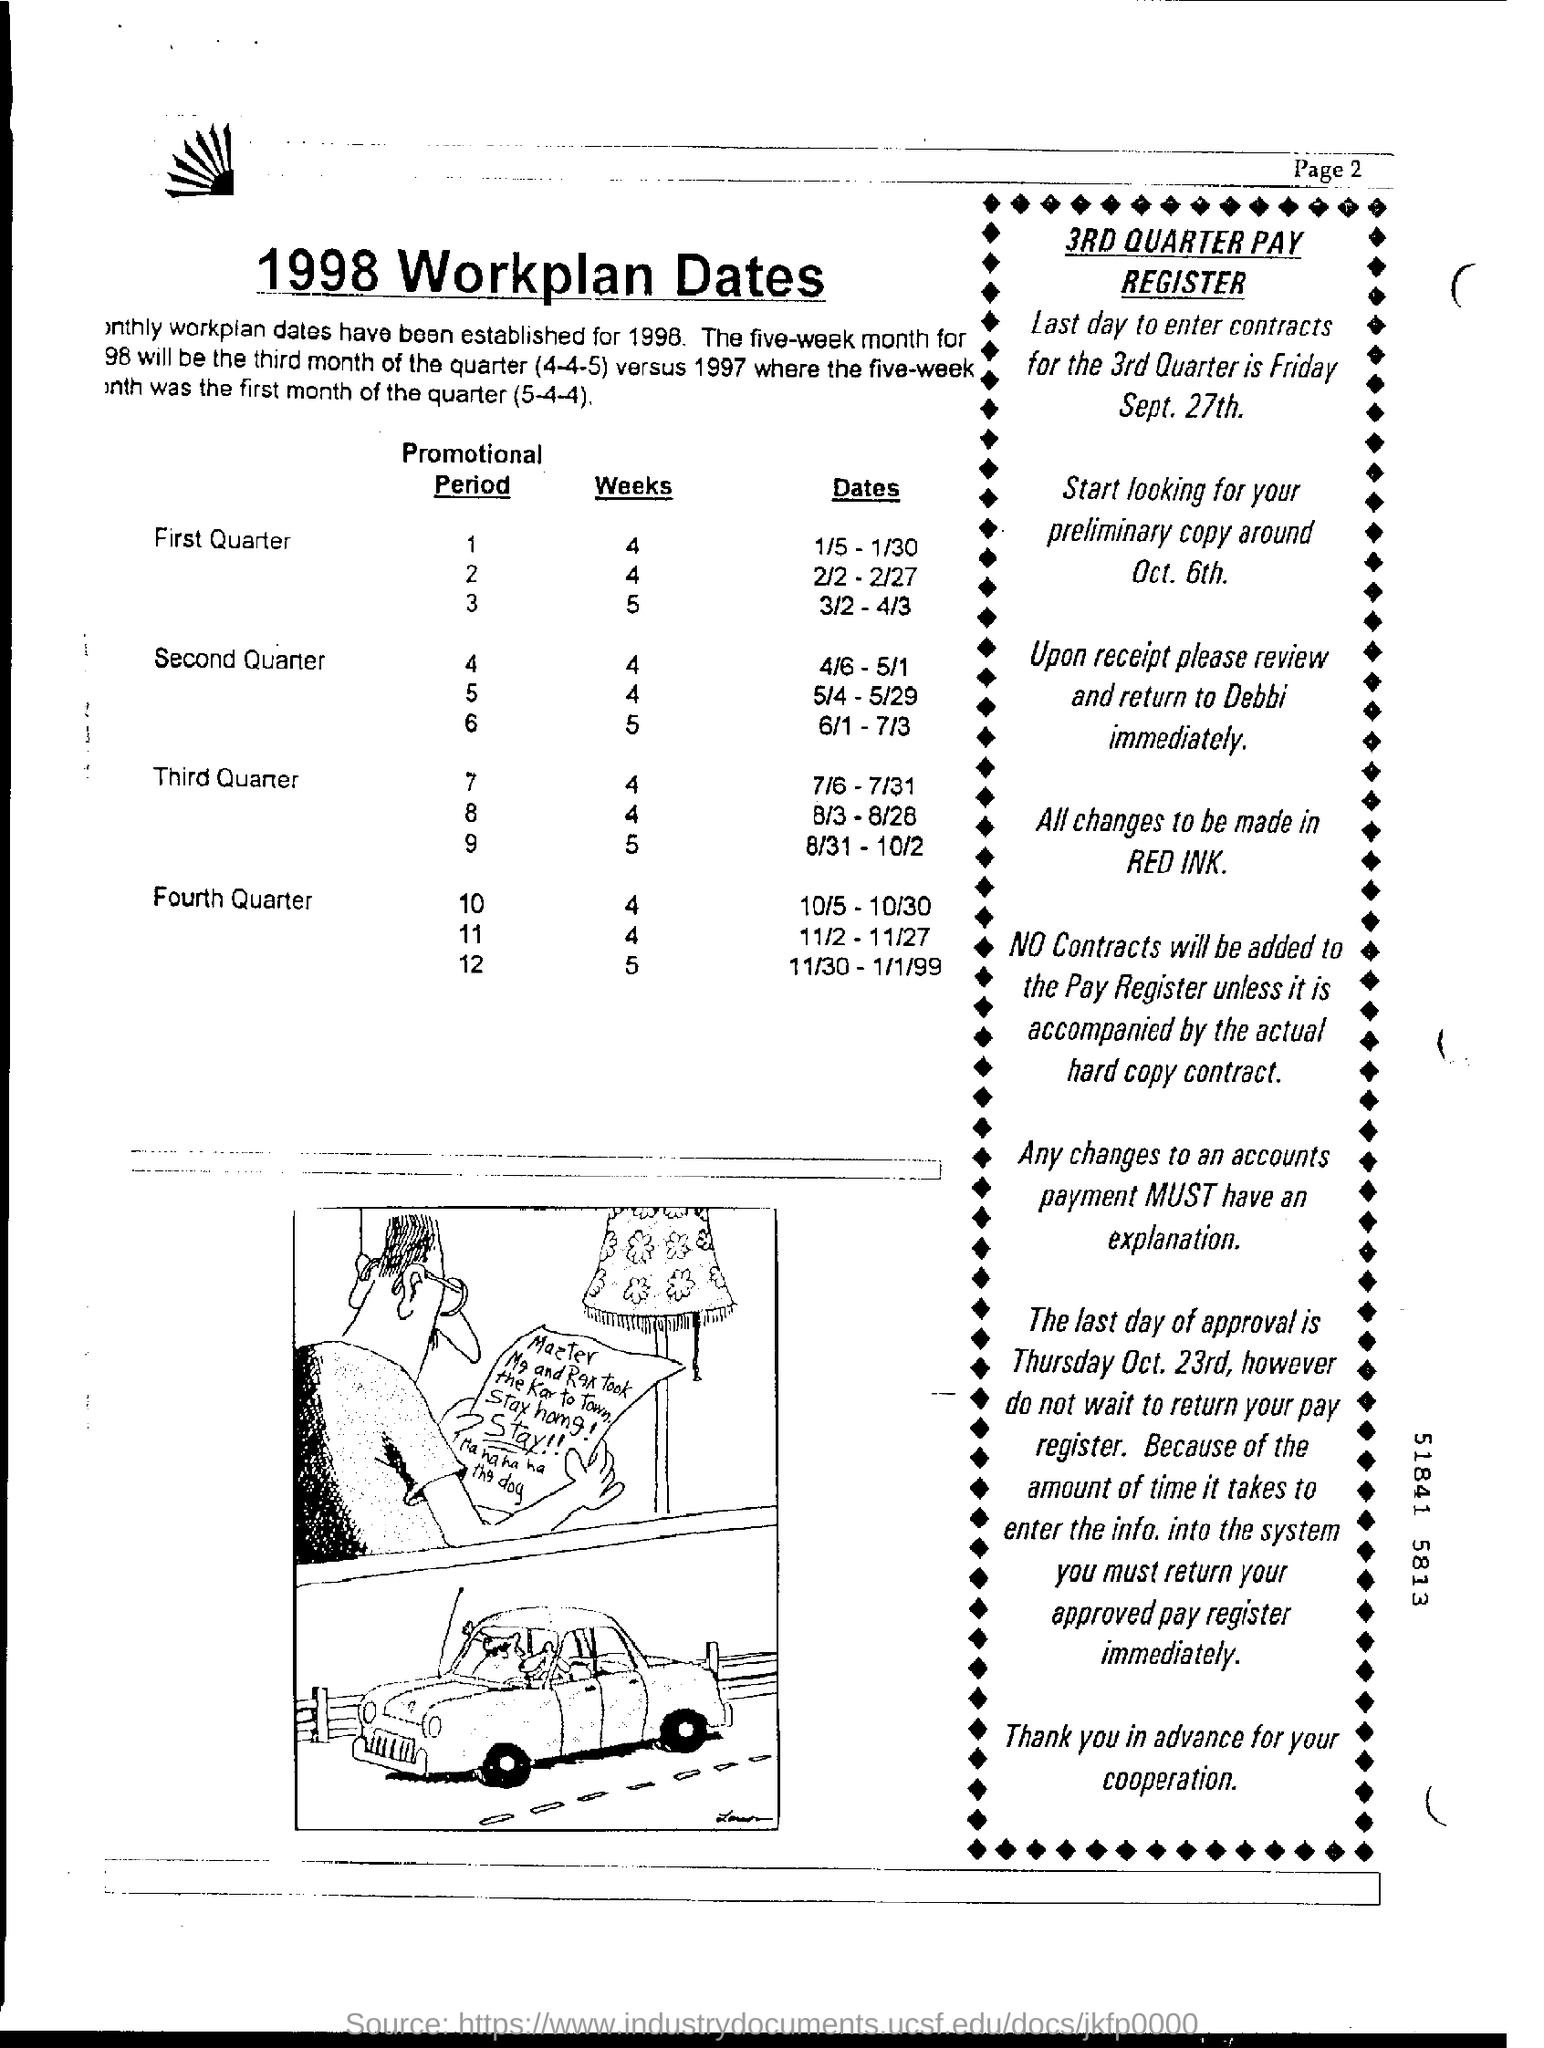Indicate a few pertinent items in this graphic. The last day of approval is Thursday, Oct. 23rd. It is the last day to enter contracts for the 3rd Quarter, which is on Friday, September 27th. 